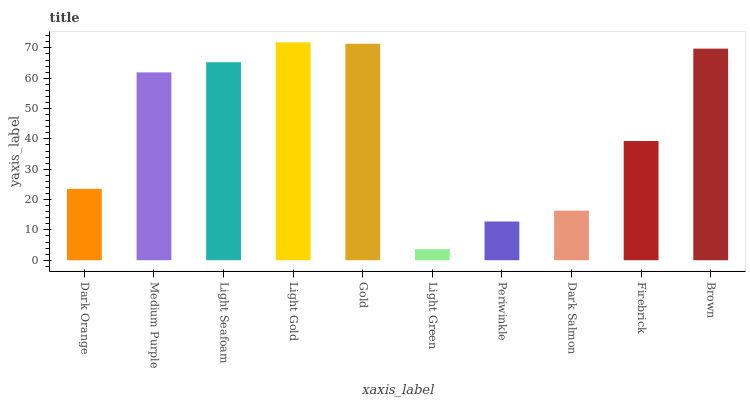Is Light Green the minimum?
Answer yes or no. Yes. Is Light Gold the maximum?
Answer yes or no. Yes. Is Medium Purple the minimum?
Answer yes or no. No. Is Medium Purple the maximum?
Answer yes or no. No. Is Medium Purple greater than Dark Orange?
Answer yes or no. Yes. Is Dark Orange less than Medium Purple?
Answer yes or no. Yes. Is Dark Orange greater than Medium Purple?
Answer yes or no. No. Is Medium Purple less than Dark Orange?
Answer yes or no. No. Is Medium Purple the high median?
Answer yes or no. Yes. Is Firebrick the low median?
Answer yes or no. Yes. Is Gold the high median?
Answer yes or no. No. Is Dark Orange the low median?
Answer yes or no. No. 